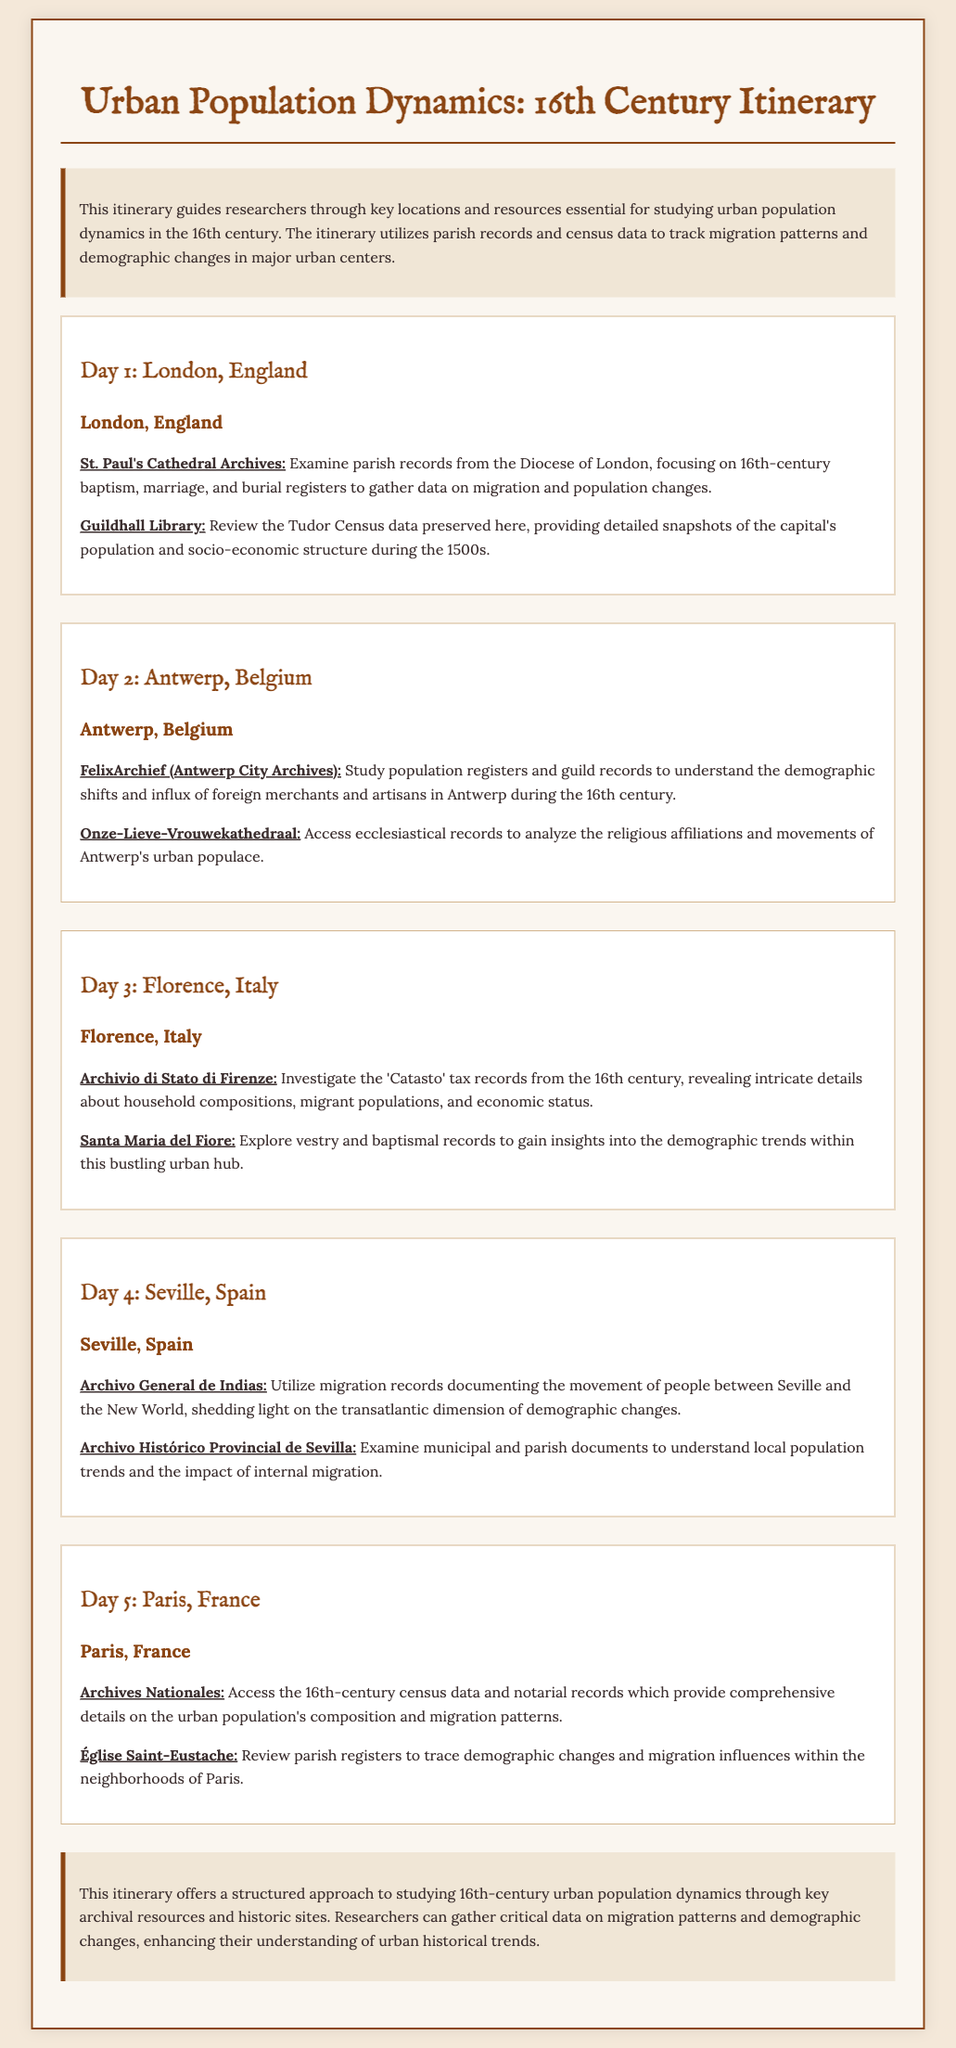What is the title of the document? The title is found in the header of the itinerary, summarizing its content and focus.
Answer: Urban Population Dynamics: 16th Century Itinerary What city is associated with the St. Paul's Cathedral Archives? This location is specified in the Day 1 section of the itinerary, highlighting its significance for the study.
Answer: London, England Which archive includes the Tudor Census data? This information is provided as part of the activities listed for Day 1, detailing where to access key demographic data.
Answer: Guildhall Library Where can one analyze the 'Catasto' tax records? The site mentioned in Day 3 specifically discusses where to find these tax records that reveal important demographic information.
Answer: Archivio di Stato di Firenze What type of records does the Archivo General de Indias provide? This question addresses the nature of the records at this archive, focused on migration and its implications.
Answer: Migration records Which religious site is referenced in connection with Antwerp's demographic analysis? The itinerary highlights the site to examine religious affiliations and movements within the city's population.
Answer: Onze-Lieve-Vrouwekathedraal How many days does the itinerary span? The total number of days is specified in the structure of the itinerary's sections.
Answer: Five days What is the focus of the itinerary for researchers? The purpose of the itinerary is clearly stated in the introduction, summarizing its aim in relation to urban population dynamics.
Answer: Studying urban population dynamics Which city is associated with the Santa Maria del Fiore? This location is listed in Day 3, connecting it to the urban studies of Florence.
Answer: Florence, Italy 